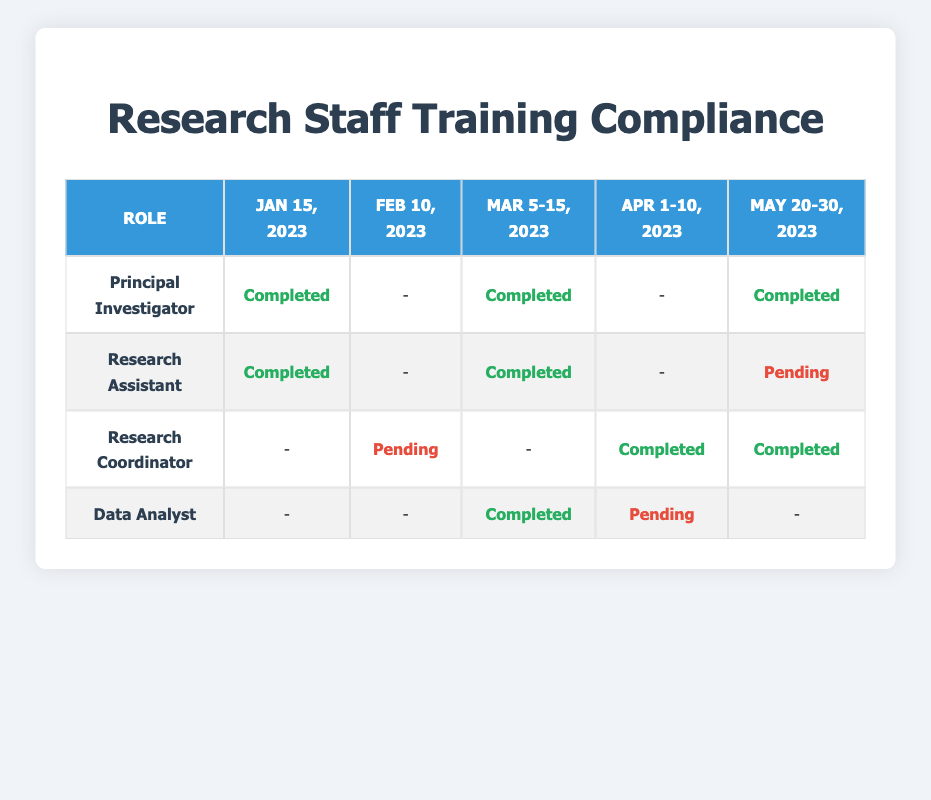What was the compliance status for Research Assistants on May 21, 2023? According to the table, the compliance status for Research Assistants on May 21, 2023, is listed as Pending.
Answer: Pending Which role had the highest number of completed training sessions in the table? The table indicates that both the Principal Investigator and Data Analyst have completed two training sessions each; however, since we look for roles with the highest completions rather than the count, the Principal Investigator is displayed more frequently with completed sessions.
Answer: Principal Investigator Is there any role that completed all training sessions listed in the table? By reviewing the compliance status across all sessions for each role, it is clear that none of the roles completed all their training sessions, as each experienced at least one pending status.
Answer: No What is the total number of training sessions conducted for Research Coordinators, and how many were completed? For Research Coordinators, there are three training sessions listed: one on February 10 (Pending), one on April 1 (Completed), and one on May 30 (Completed). Out of these, two were marked as Completed.
Answer: 3 sessions; 2 completed How many roles show a Pending compliance status for the training sessions in total? By examining the table, Research Coordinator had one Pending (on Feb 10) and Research Assistant had one Pending (on May 21). Thus there are a total of two roles with Pending statuses across the training sessions.
Answer: 2 roles 